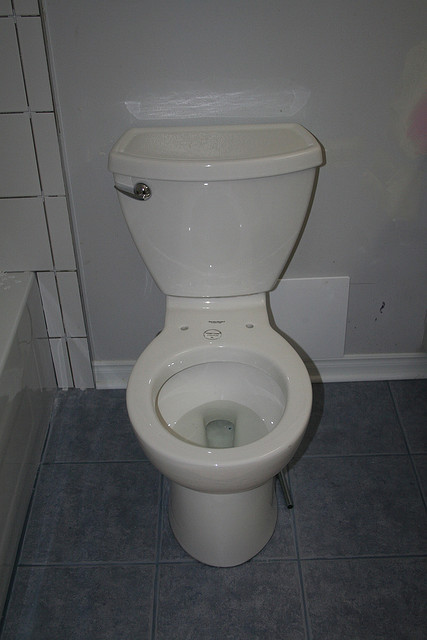<image>What company is written on the top of the commode? It is unknown what company is written on the top of the commode. There might not be any company name written. Does the bottom of the toilet cover only one flooring tile? I am not sure if the bottom of the toilet cover only one flooring tile. It can be both yes or no. What company is written on the top of the commode? I am not sure what company is written on the top of the commode. It is unknown. Does the bottom of the toilet cover only one flooring tile? The statement is ambiguous. The bottom of the toilet cover may cover more than one flooring tile or it may not. 